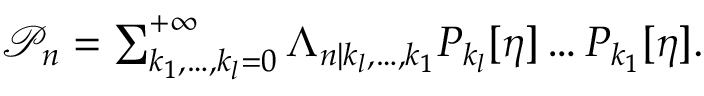Convert formula to latex. <formula><loc_0><loc_0><loc_500><loc_500>\begin{array} { r } { \mathcal { P } _ { n } = \sum _ { k _ { 1 } , \dots , k _ { l } = 0 } ^ { + \infty } \Lambda _ { n | k _ { l } , \dots , k _ { 1 } } P _ { k _ { l } } [ \eta ] \dots P _ { k _ { 1 } } [ \eta ] . } \end{array}</formula> 